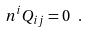<formula> <loc_0><loc_0><loc_500><loc_500>n ^ { i } Q _ { i j } = 0 \ .</formula> 